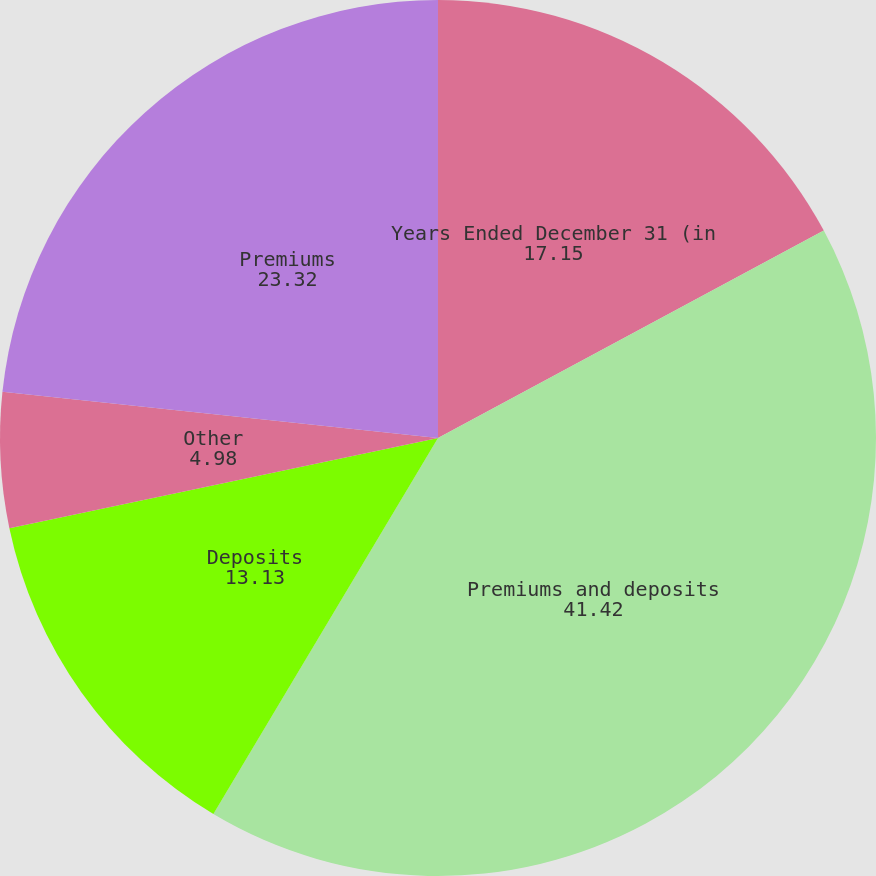Convert chart to OTSL. <chart><loc_0><loc_0><loc_500><loc_500><pie_chart><fcel>Years Ended December 31 (in<fcel>Premiums and deposits<fcel>Deposits<fcel>Other<fcel>Premiums<nl><fcel>17.15%<fcel>41.42%<fcel>13.13%<fcel>4.98%<fcel>23.32%<nl></chart> 